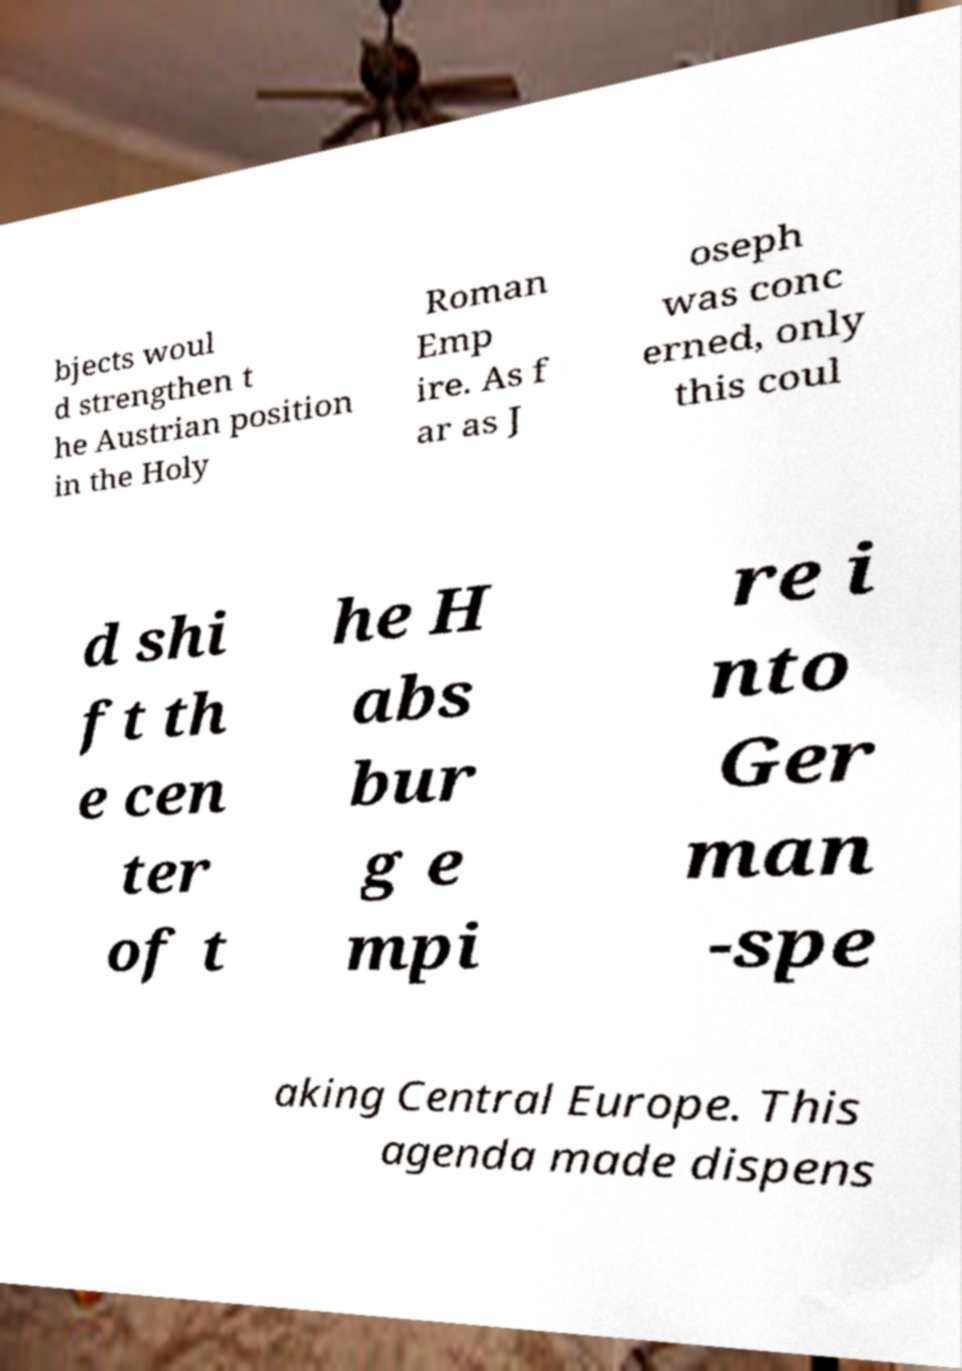Can you accurately transcribe the text from the provided image for me? bjects woul d strengthen t he Austrian position in the Holy Roman Emp ire. As f ar as J oseph was conc erned, only this coul d shi ft th e cen ter of t he H abs bur g e mpi re i nto Ger man -spe aking Central Europe. This agenda made dispens 